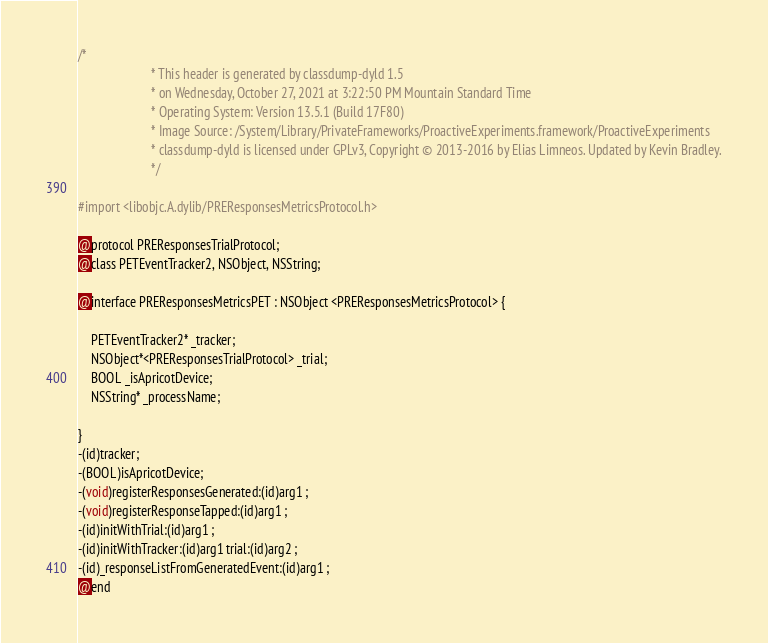Convert code to text. <code><loc_0><loc_0><loc_500><loc_500><_C_>/*
                       * This header is generated by classdump-dyld 1.5
                       * on Wednesday, October 27, 2021 at 3:22:50 PM Mountain Standard Time
                       * Operating System: Version 13.5.1 (Build 17F80)
                       * Image Source: /System/Library/PrivateFrameworks/ProactiveExperiments.framework/ProactiveExperiments
                       * classdump-dyld is licensed under GPLv3, Copyright © 2013-2016 by Elias Limneos. Updated by Kevin Bradley.
                       */

#import <libobjc.A.dylib/PREResponsesMetricsProtocol.h>

@protocol PREResponsesTrialProtocol;
@class PETEventTracker2, NSObject, NSString;

@interface PREResponsesMetricsPET : NSObject <PREResponsesMetricsProtocol> {

	PETEventTracker2* _tracker;
	NSObject*<PREResponsesTrialProtocol> _trial;
	BOOL _isApricotDevice;
	NSString* _processName;

}
-(id)tracker;
-(BOOL)isApricotDevice;
-(void)registerResponsesGenerated:(id)arg1 ;
-(void)registerResponseTapped:(id)arg1 ;
-(id)initWithTrial:(id)arg1 ;
-(id)initWithTracker:(id)arg1 trial:(id)arg2 ;
-(id)_responseListFromGeneratedEvent:(id)arg1 ;
@end

</code> 